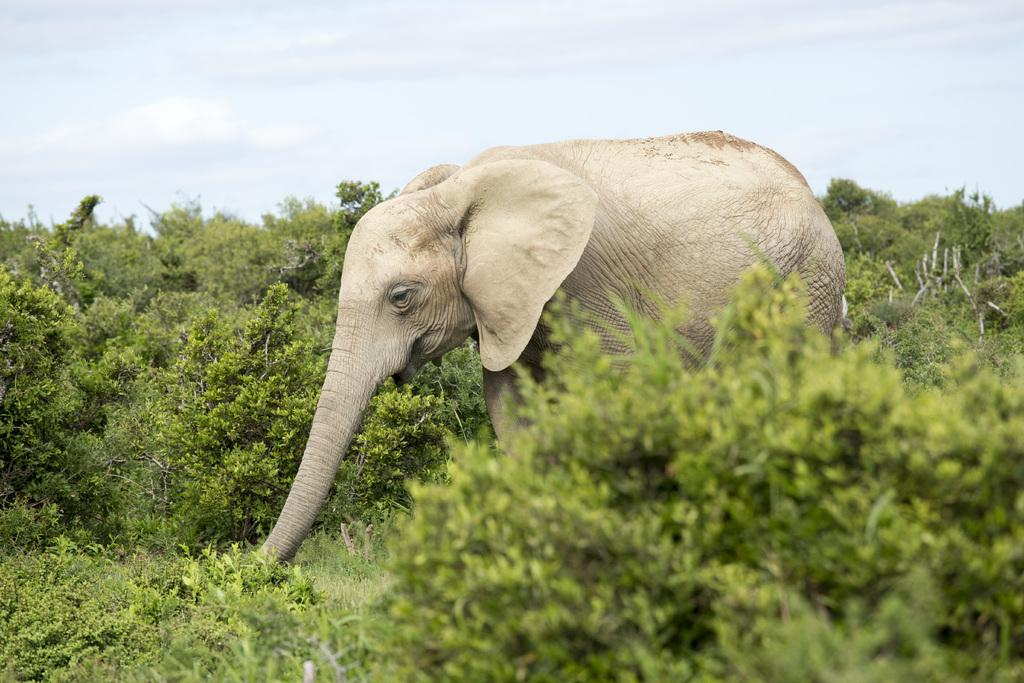What is the main subject in the foreground of the image? There is an elephant in the foreground of the image. What else can be seen in the foreground of the image besides the elephant? There is greenery in the foreground of the image. What is visible in the background of the image? The sky is visible in the background of the image. Where is the secretary sitting with the loaf of bread in the image? There is no secretary or loaf of bread present in the image. Can you describe the tub that the elephant is standing in the image? There is no tub in the image; the elephant is standing on greenery in the foreground. 